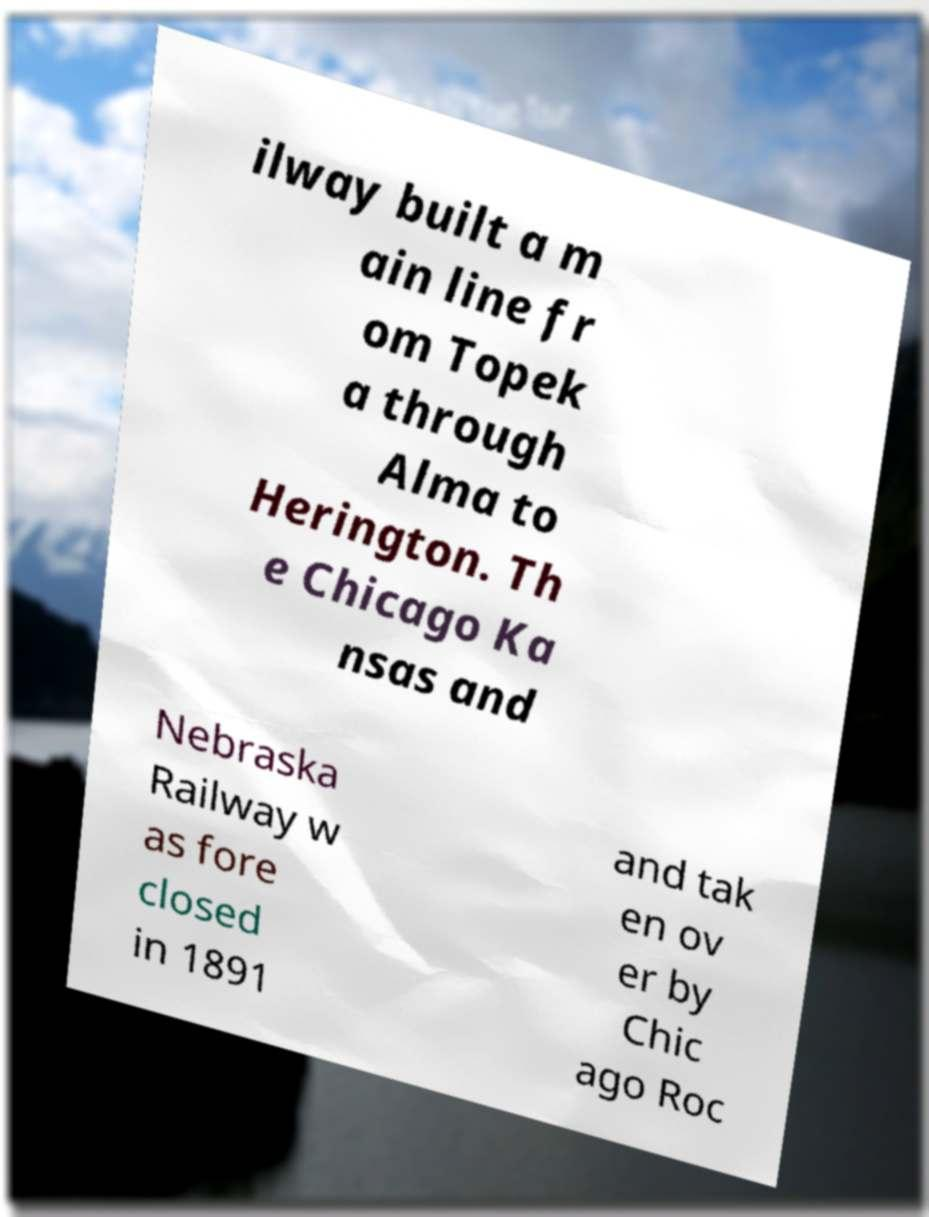Please identify and transcribe the text found in this image. ilway built a m ain line fr om Topek a through Alma to Herington. Th e Chicago Ka nsas and Nebraska Railway w as fore closed in 1891 and tak en ov er by Chic ago Roc 